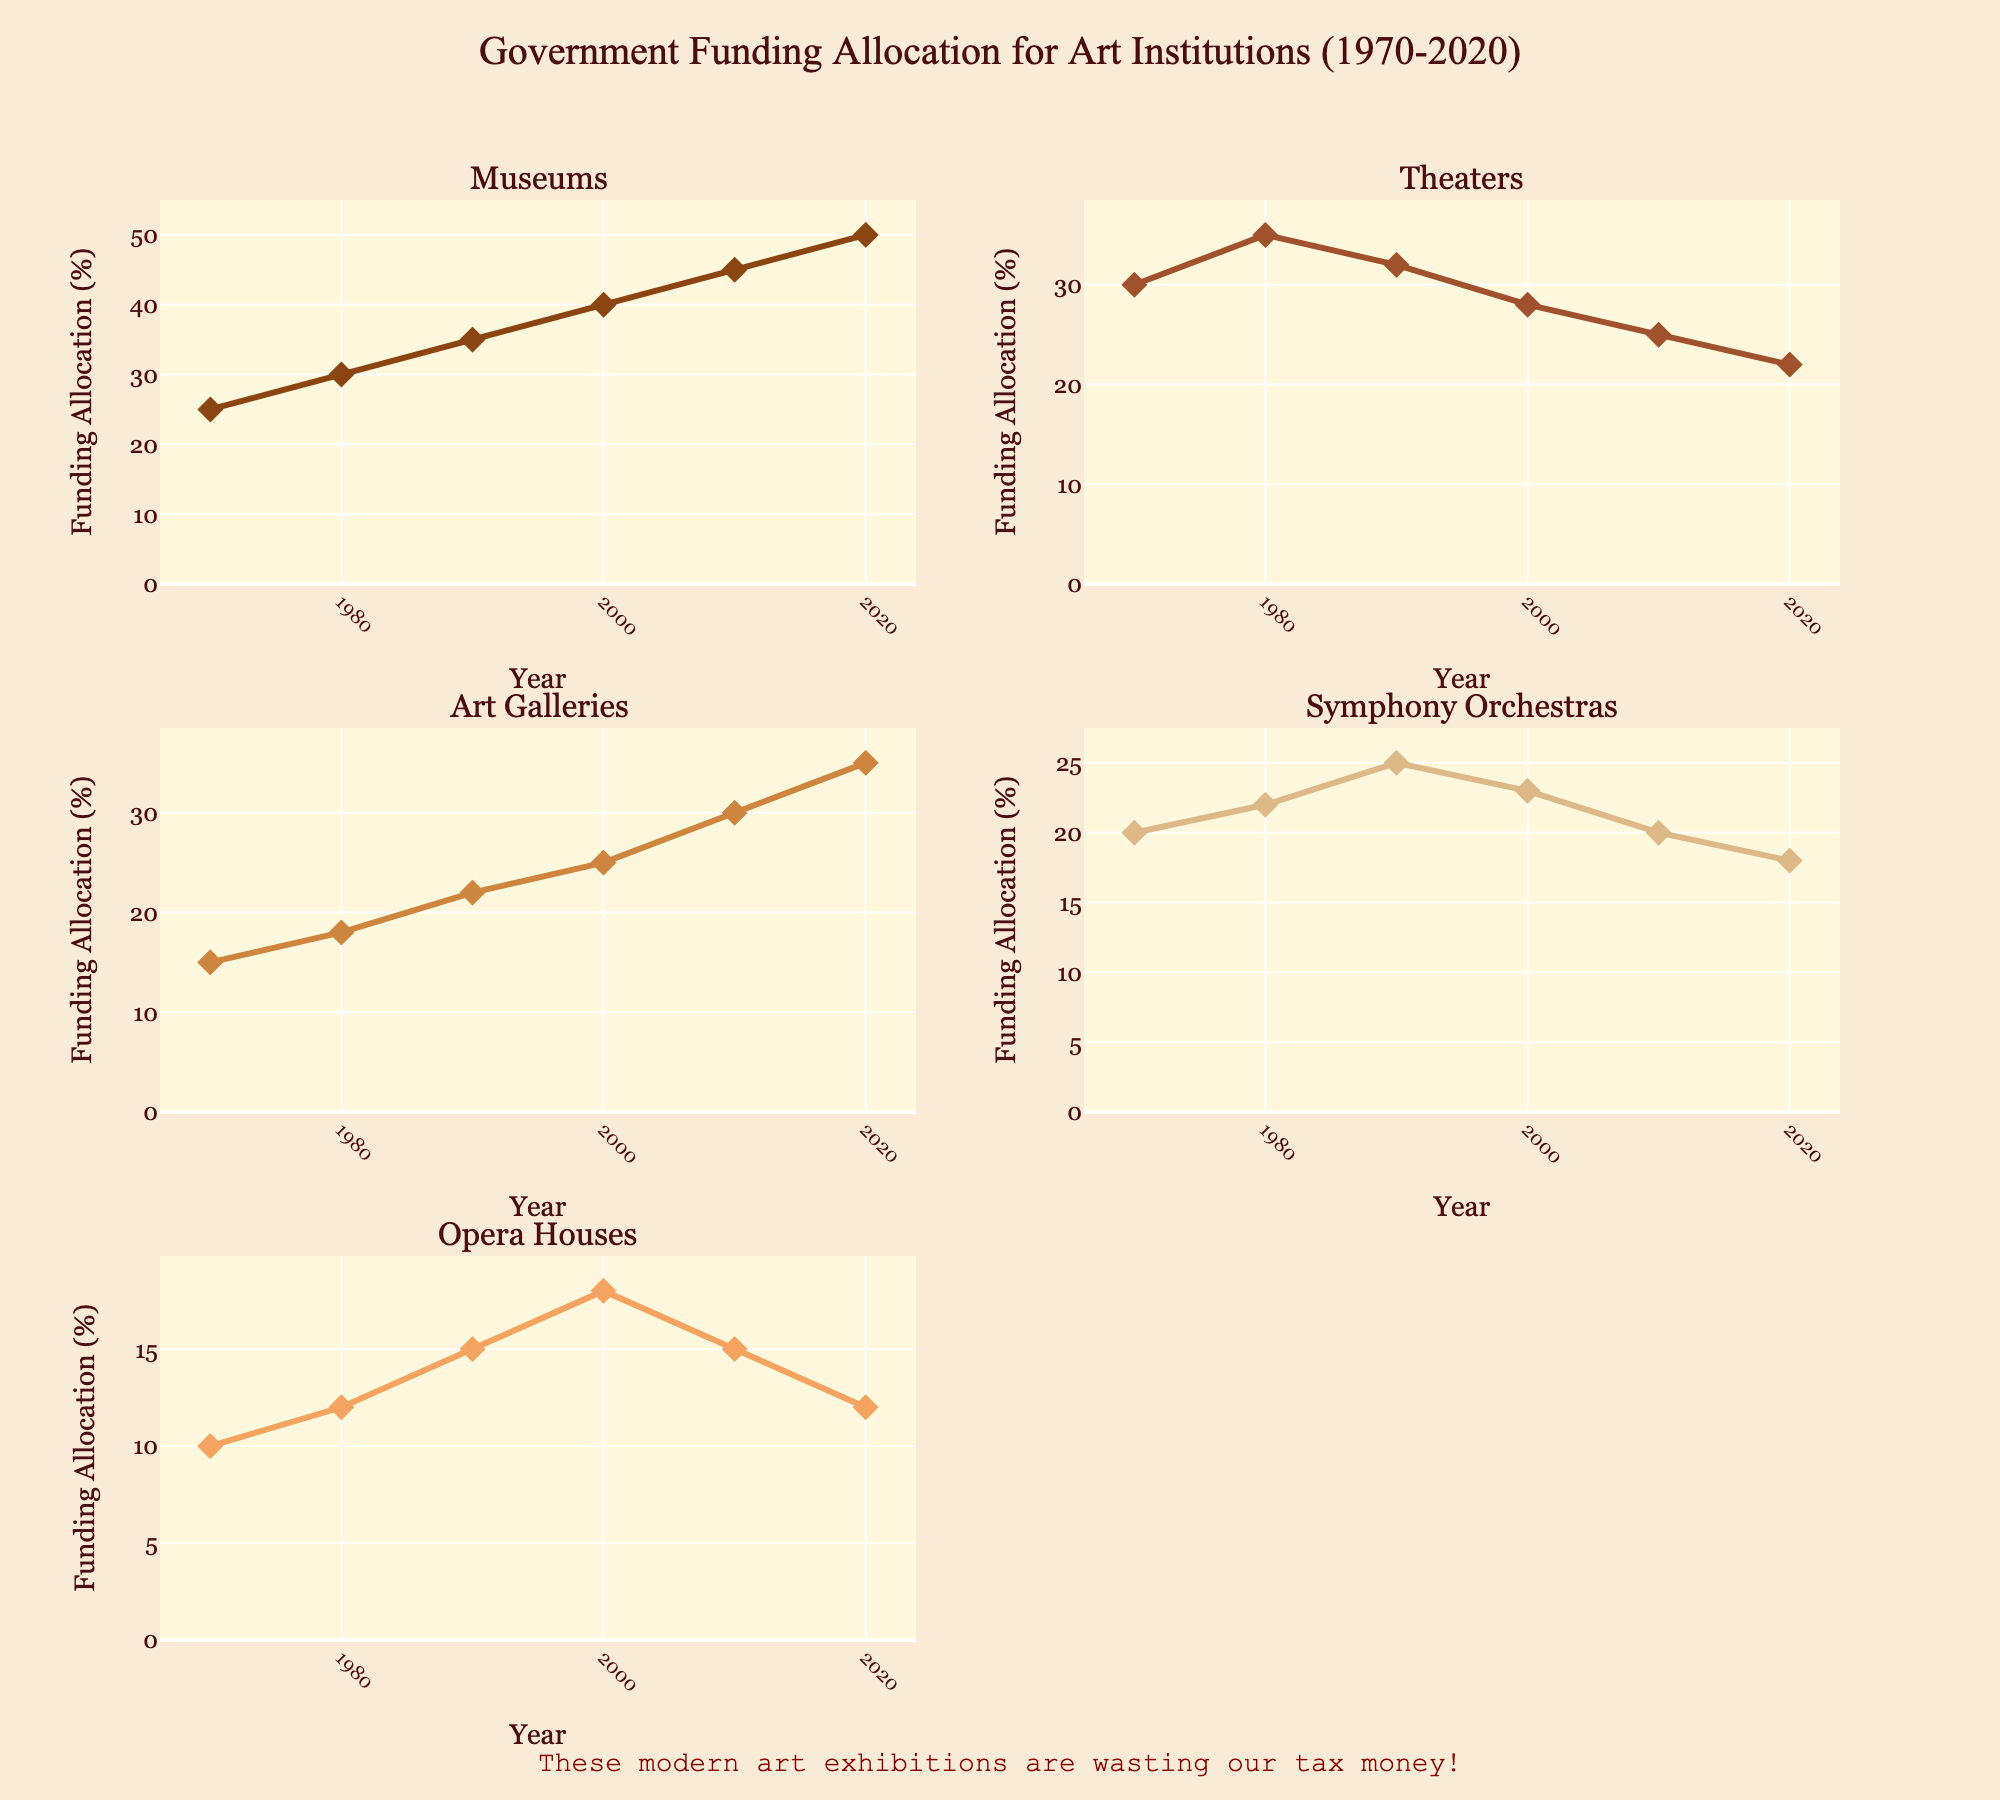what is the title of the figure? The title is located at the top center of the figure, highlighted by its placement and formatting. It reads: "Government Funding Allocation for Art Institutions (1970-2020)".
Answer: Government Funding Allocation for Art Institutions (1970-2020) How did the funding for art galleries change from 1970 to 2020? The subplot for "Art Galleries" shows an increasing trend. In 1970, the funding was at 15%. By 2020, the funding had increased to 35%.
Answer: Increased from 15% to 35% Which type of institution received the least funding in 2020? The subplot values for 2020 indicate that Opera Houses received the least funding, with a percentage of 12%.
Answer: Opera Houses Calculate the average funding for symphony orchestras across all years shown. The subplots for "Symphony Orchestras" show funding values of 20%, 22%, 25%, 23%, 20%, and 18% for the years 1970, 1980, 1990, 2000, 2010, and 2020 respectively. The average is calculated as (20 + 22 + 25 + 23 + 20 + 18) / 6 = 21.33%.
Answer: 21.33% Which type of institution had the largest decrease in funding between 1970 and 2020? The subplots indicate that Theaters had a funding level of 30% in 1970 and 22% in 2020. This represents a decrease of 8%, which is the largest observed among the institutions.
Answer: Theaters How many types of art institutions are compared in the figure? There are a total of 5 different types of art institutions compared, as seen from the subplot titles: Museums, Theaters, Art Galleries, Symphony Orchestras, and Opera Houses.
Answer: 5 Between which consecutive decades did Opera Houses see an increase in funding? By examining the subplot for "Opera Houses", funding increased from the 1970s (10%) to the 1980s (12%) and again from the 1980s (12%) to the 1990s (15%). So, the consecutive decades where this increase occurred were from the 1970s to 1980s and from the 1980s to 1990s.
Answer: 1970s to 1980s, and 1980s to 1990s What is the funding allocation for Museums in 1990, and how does it compare to the funding for Art Galleries in 1990? The subplot for "Museums" shows 35% in 1990 and for "Art Galleries" it shows 22% in the same year. Calculating the difference, Museums received 13% more funding than Art Galleries in 1990.
Answer: 35% (Museums) and 22% (Art Galleries); 13% more for Museums 